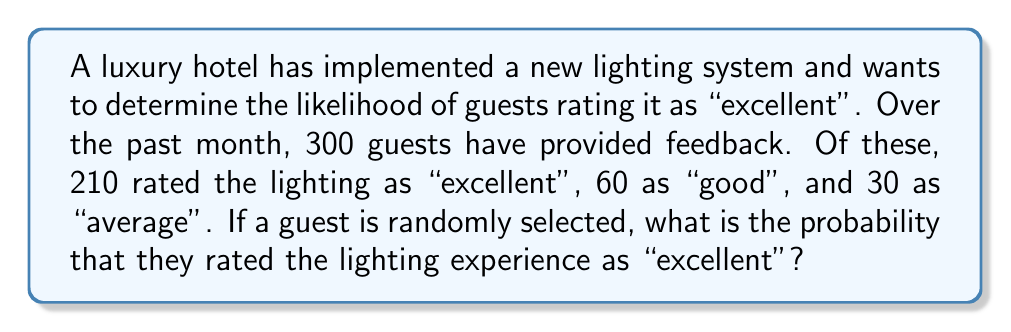Show me your answer to this math problem. To solve this problem, we'll use the concept of probability based on relative frequency.

Step 1: Identify the total number of guests who provided feedback.
Total guests = 210 + 60 + 30 = 300

Step 2: Identify the number of guests who rated the lighting as "excellent".
Excellent ratings = 210

Step 3: Calculate the probability using the formula:
$$P(\text{Excellent}) = \frac{\text{Number of favorable outcomes}}{\text{Total number of possible outcomes}}$$

$$P(\text{Excellent}) = \frac{210}{300}$$

Step 4: Simplify the fraction:
$$P(\text{Excellent}) = \frac{7}{10} = 0.7$$

Therefore, the probability of a randomly selected guest rating the lighting experience as "excellent" is 0.7 or 70%.
Answer: 0.7 